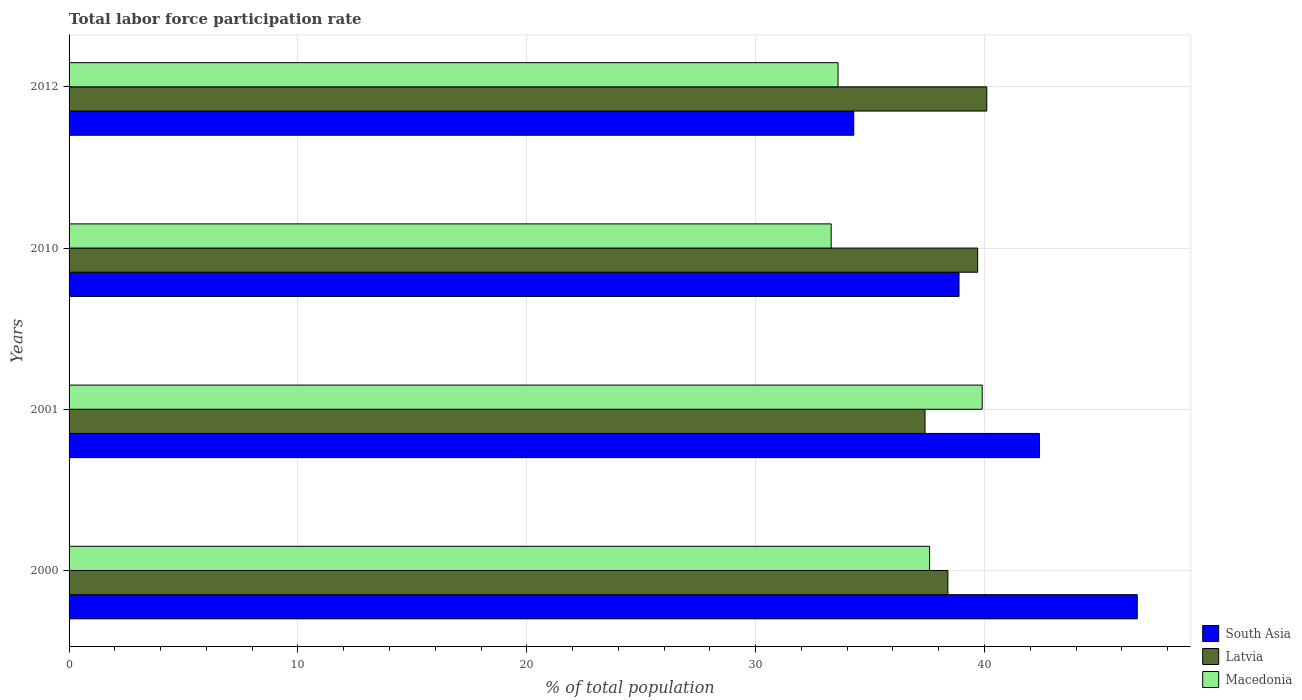Are the number of bars on each tick of the Y-axis equal?
Your answer should be very brief. Yes. How many bars are there on the 4th tick from the top?
Your answer should be compact. 3. What is the total labor force participation rate in Macedonia in 2010?
Provide a short and direct response. 33.3. Across all years, what is the maximum total labor force participation rate in Latvia?
Ensure brevity in your answer.  40.1. Across all years, what is the minimum total labor force participation rate in Macedonia?
Ensure brevity in your answer.  33.3. What is the total total labor force participation rate in South Asia in the graph?
Ensure brevity in your answer.  162.25. What is the difference between the total labor force participation rate in Latvia in 2001 and that in 2010?
Your response must be concise. -2.3. What is the difference between the total labor force participation rate in Latvia in 2010 and the total labor force participation rate in Macedonia in 2012?
Provide a short and direct response. 6.1. What is the average total labor force participation rate in Latvia per year?
Provide a succinct answer. 38.9. In the year 2001, what is the difference between the total labor force participation rate in Macedonia and total labor force participation rate in Latvia?
Offer a terse response. 2.5. What is the ratio of the total labor force participation rate in Latvia in 2001 to that in 2012?
Make the answer very short. 0.93. Is the difference between the total labor force participation rate in Macedonia in 2000 and 2012 greater than the difference between the total labor force participation rate in Latvia in 2000 and 2012?
Offer a terse response. Yes. What is the difference between the highest and the second highest total labor force participation rate in Macedonia?
Ensure brevity in your answer.  2.3. What is the difference between the highest and the lowest total labor force participation rate in Macedonia?
Provide a succinct answer. 6.6. In how many years, is the total labor force participation rate in Latvia greater than the average total labor force participation rate in Latvia taken over all years?
Your answer should be very brief. 2. Is the sum of the total labor force participation rate in Macedonia in 2000 and 2010 greater than the maximum total labor force participation rate in South Asia across all years?
Keep it short and to the point. Yes. What does the 2nd bar from the bottom in 2012 represents?
Offer a terse response. Latvia. Are all the bars in the graph horizontal?
Provide a short and direct response. Yes. Are the values on the major ticks of X-axis written in scientific E-notation?
Make the answer very short. No. Does the graph contain grids?
Offer a very short reply. Yes. Where does the legend appear in the graph?
Keep it short and to the point. Bottom right. How are the legend labels stacked?
Provide a succinct answer. Vertical. What is the title of the graph?
Keep it short and to the point. Total labor force participation rate. Does "Netherlands" appear as one of the legend labels in the graph?
Provide a succinct answer. No. What is the label or title of the X-axis?
Ensure brevity in your answer.  % of total population. What is the label or title of the Y-axis?
Provide a succinct answer. Years. What is the % of total population of South Asia in 2000?
Keep it short and to the point. 46.67. What is the % of total population in Latvia in 2000?
Ensure brevity in your answer.  38.4. What is the % of total population of Macedonia in 2000?
Offer a terse response. 37.6. What is the % of total population of South Asia in 2001?
Your answer should be very brief. 42.4. What is the % of total population in Latvia in 2001?
Ensure brevity in your answer.  37.4. What is the % of total population in Macedonia in 2001?
Offer a very short reply. 39.9. What is the % of total population of South Asia in 2010?
Offer a terse response. 38.89. What is the % of total population of Latvia in 2010?
Provide a short and direct response. 39.7. What is the % of total population of Macedonia in 2010?
Make the answer very short. 33.3. What is the % of total population of South Asia in 2012?
Your response must be concise. 34.29. What is the % of total population of Latvia in 2012?
Ensure brevity in your answer.  40.1. What is the % of total population of Macedonia in 2012?
Your response must be concise. 33.6. Across all years, what is the maximum % of total population of South Asia?
Provide a succinct answer. 46.67. Across all years, what is the maximum % of total population of Latvia?
Give a very brief answer. 40.1. Across all years, what is the maximum % of total population in Macedonia?
Your answer should be compact. 39.9. Across all years, what is the minimum % of total population of South Asia?
Your answer should be very brief. 34.29. Across all years, what is the minimum % of total population in Latvia?
Make the answer very short. 37.4. Across all years, what is the minimum % of total population in Macedonia?
Your answer should be very brief. 33.3. What is the total % of total population in South Asia in the graph?
Provide a succinct answer. 162.25. What is the total % of total population in Latvia in the graph?
Your answer should be compact. 155.6. What is the total % of total population of Macedonia in the graph?
Give a very brief answer. 144.4. What is the difference between the % of total population in South Asia in 2000 and that in 2001?
Give a very brief answer. 4.27. What is the difference between the % of total population in Latvia in 2000 and that in 2001?
Your response must be concise. 1. What is the difference between the % of total population in South Asia in 2000 and that in 2010?
Your answer should be compact. 7.79. What is the difference between the % of total population of Latvia in 2000 and that in 2010?
Keep it short and to the point. -1.3. What is the difference between the % of total population of Macedonia in 2000 and that in 2010?
Your response must be concise. 4.3. What is the difference between the % of total population of South Asia in 2000 and that in 2012?
Offer a terse response. 12.39. What is the difference between the % of total population of Macedonia in 2000 and that in 2012?
Provide a short and direct response. 4. What is the difference between the % of total population in South Asia in 2001 and that in 2010?
Keep it short and to the point. 3.51. What is the difference between the % of total population of Macedonia in 2001 and that in 2010?
Offer a very short reply. 6.6. What is the difference between the % of total population of South Asia in 2001 and that in 2012?
Offer a very short reply. 8.11. What is the difference between the % of total population in Latvia in 2001 and that in 2012?
Make the answer very short. -2.7. What is the difference between the % of total population in South Asia in 2010 and that in 2012?
Make the answer very short. 4.6. What is the difference between the % of total population of South Asia in 2000 and the % of total population of Latvia in 2001?
Provide a short and direct response. 9.27. What is the difference between the % of total population of South Asia in 2000 and the % of total population of Macedonia in 2001?
Offer a very short reply. 6.77. What is the difference between the % of total population in South Asia in 2000 and the % of total population in Latvia in 2010?
Give a very brief answer. 6.97. What is the difference between the % of total population of South Asia in 2000 and the % of total population of Macedonia in 2010?
Your answer should be compact. 13.37. What is the difference between the % of total population in Latvia in 2000 and the % of total population in Macedonia in 2010?
Offer a very short reply. 5.1. What is the difference between the % of total population in South Asia in 2000 and the % of total population in Latvia in 2012?
Offer a terse response. 6.57. What is the difference between the % of total population in South Asia in 2000 and the % of total population in Macedonia in 2012?
Ensure brevity in your answer.  13.07. What is the difference between the % of total population of South Asia in 2001 and the % of total population of Macedonia in 2010?
Provide a short and direct response. 9.1. What is the difference between the % of total population in South Asia in 2001 and the % of total population in Latvia in 2012?
Make the answer very short. 2.3. What is the difference between the % of total population of South Asia in 2001 and the % of total population of Macedonia in 2012?
Your response must be concise. 8.8. What is the difference between the % of total population in Latvia in 2001 and the % of total population in Macedonia in 2012?
Provide a succinct answer. 3.8. What is the difference between the % of total population of South Asia in 2010 and the % of total population of Latvia in 2012?
Your answer should be compact. -1.21. What is the difference between the % of total population in South Asia in 2010 and the % of total population in Macedonia in 2012?
Your response must be concise. 5.29. What is the difference between the % of total population of Latvia in 2010 and the % of total population of Macedonia in 2012?
Offer a very short reply. 6.1. What is the average % of total population in South Asia per year?
Your answer should be compact. 40.56. What is the average % of total population in Latvia per year?
Provide a succinct answer. 38.9. What is the average % of total population of Macedonia per year?
Your response must be concise. 36.1. In the year 2000, what is the difference between the % of total population of South Asia and % of total population of Latvia?
Your response must be concise. 8.27. In the year 2000, what is the difference between the % of total population in South Asia and % of total population in Macedonia?
Your answer should be very brief. 9.07. In the year 2001, what is the difference between the % of total population of South Asia and % of total population of Macedonia?
Keep it short and to the point. 2.5. In the year 2001, what is the difference between the % of total population in Latvia and % of total population in Macedonia?
Offer a very short reply. -2.5. In the year 2010, what is the difference between the % of total population in South Asia and % of total population in Latvia?
Your answer should be compact. -0.81. In the year 2010, what is the difference between the % of total population in South Asia and % of total population in Macedonia?
Ensure brevity in your answer.  5.59. In the year 2010, what is the difference between the % of total population of Latvia and % of total population of Macedonia?
Offer a very short reply. 6.4. In the year 2012, what is the difference between the % of total population in South Asia and % of total population in Latvia?
Provide a succinct answer. -5.81. In the year 2012, what is the difference between the % of total population of South Asia and % of total population of Macedonia?
Your answer should be compact. 0.69. In the year 2012, what is the difference between the % of total population of Latvia and % of total population of Macedonia?
Offer a very short reply. 6.5. What is the ratio of the % of total population in South Asia in 2000 to that in 2001?
Your response must be concise. 1.1. What is the ratio of the % of total population in Latvia in 2000 to that in 2001?
Provide a short and direct response. 1.03. What is the ratio of the % of total population in Macedonia in 2000 to that in 2001?
Give a very brief answer. 0.94. What is the ratio of the % of total population of South Asia in 2000 to that in 2010?
Offer a very short reply. 1.2. What is the ratio of the % of total population in Latvia in 2000 to that in 2010?
Make the answer very short. 0.97. What is the ratio of the % of total population in Macedonia in 2000 to that in 2010?
Offer a very short reply. 1.13. What is the ratio of the % of total population in South Asia in 2000 to that in 2012?
Ensure brevity in your answer.  1.36. What is the ratio of the % of total population in Latvia in 2000 to that in 2012?
Offer a terse response. 0.96. What is the ratio of the % of total population in Macedonia in 2000 to that in 2012?
Make the answer very short. 1.12. What is the ratio of the % of total population in South Asia in 2001 to that in 2010?
Provide a succinct answer. 1.09. What is the ratio of the % of total population in Latvia in 2001 to that in 2010?
Provide a succinct answer. 0.94. What is the ratio of the % of total population of Macedonia in 2001 to that in 2010?
Provide a short and direct response. 1.2. What is the ratio of the % of total population of South Asia in 2001 to that in 2012?
Keep it short and to the point. 1.24. What is the ratio of the % of total population in Latvia in 2001 to that in 2012?
Your answer should be very brief. 0.93. What is the ratio of the % of total population of Macedonia in 2001 to that in 2012?
Your answer should be very brief. 1.19. What is the ratio of the % of total population in South Asia in 2010 to that in 2012?
Make the answer very short. 1.13. What is the ratio of the % of total population of Macedonia in 2010 to that in 2012?
Make the answer very short. 0.99. What is the difference between the highest and the second highest % of total population in South Asia?
Your answer should be compact. 4.27. What is the difference between the highest and the second highest % of total population of Latvia?
Your response must be concise. 0.4. What is the difference between the highest and the lowest % of total population in South Asia?
Your answer should be compact. 12.39. What is the difference between the highest and the lowest % of total population of Latvia?
Your response must be concise. 2.7. 